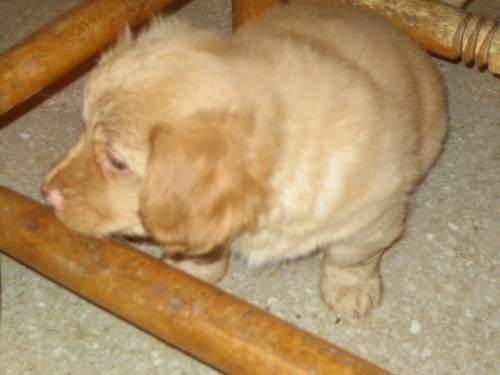Can you describe the main subject's appearance? The main subject appears to be a young puppy with a light brown coat. The puppy seems to be in a crouched position, possibly exploring its surroundings. Due to the image's quality, finer details are not easily discernible. 